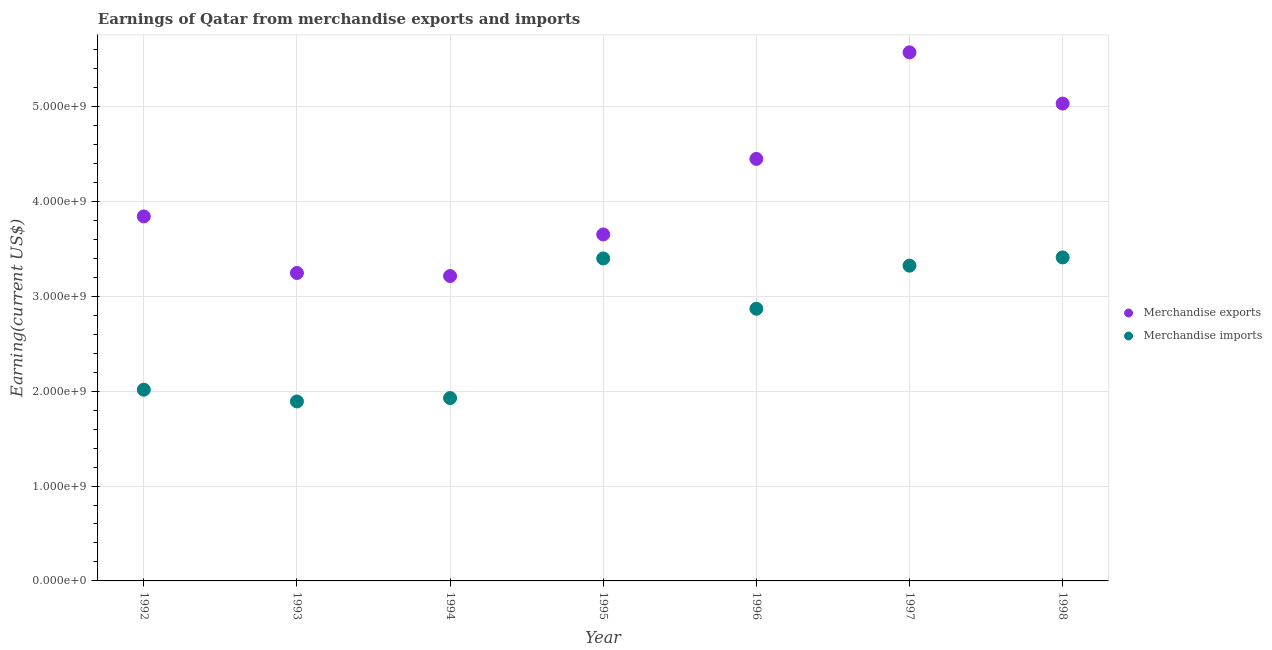How many different coloured dotlines are there?
Provide a short and direct response. 2. Is the number of dotlines equal to the number of legend labels?
Offer a terse response. Yes. What is the earnings from merchandise exports in 1993?
Provide a short and direct response. 3.24e+09. Across all years, what is the maximum earnings from merchandise imports?
Provide a short and direct response. 3.41e+09. Across all years, what is the minimum earnings from merchandise exports?
Provide a succinct answer. 3.21e+09. In which year was the earnings from merchandise exports maximum?
Your response must be concise. 1997. What is the total earnings from merchandise imports in the graph?
Keep it short and to the point. 1.88e+1. What is the difference between the earnings from merchandise exports in 1995 and that in 1997?
Ensure brevity in your answer.  -1.92e+09. What is the difference between the earnings from merchandise exports in 1997 and the earnings from merchandise imports in 1993?
Your response must be concise. 3.68e+09. What is the average earnings from merchandise imports per year?
Keep it short and to the point. 2.69e+09. In the year 1996, what is the difference between the earnings from merchandise exports and earnings from merchandise imports?
Your answer should be compact. 1.58e+09. In how many years, is the earnings from merchandise exports greater than 3400000000 US$?
Offer a terse response. 5. What is the ratio of the earnings from merchandise imports in 1995 to that in 1998?
Provide a short and direct response. 1. What is the difference between the highest and the second highest earnings from merchandise imports?
Offer a very short reply. 1.10e+07. What is the difference between the highest and the lowest earnings from merchandise imports?
Make the answer very short. 1.52e+09. Is the sum of the earnings from merchandise imports in 1994 and 1997 greater than the maximum earnings from merchandise exports across all years?
Ensure brevity in your answer.  No. Is the earnings from merchandise exports strictly greater than the earnings from merchandise imports over the years?
Your answer should be compact. Yes. Is the earnings from merchandise imports strictly less than the earnings from merchandise exports over the years?
Your answer should be very brief. Yes. How many dotlines are there?
Your answer should be compact. 2. How many years are there in the graph?
Your response must be concise. 7. Are the values on the major ticks of Y-axis written in scientific E-notation?
Make the answer very short. Yes. Does the graph contain grids?
Offer a very short reply. Yes. How many legend labels are there?
Your response must be concise. 2. How are the legend labels stacked?
Your response must be concise. Vertical. What is the title of the graph?
Offer a very short reply. Earnings of Qatar from merchandise exports and imports. Does "Total Population" appear as one of the legend labels in the graph?
Make the answer very short. No. What is the label or title of the X-axis?
Provide a short and direct response. Year. What is the label or title of the Y-axis?
Give a very brief answer. Earning(current US$). What is the Earning(current US$) of Merchandise exports in 1992?
Keep it short and to the point. 3.84e+09. What is the Earning(current US$) of Merchandise imports in 1992?
Your answer should be compact. 2.02e+09. What is the Earning(current US$) of Merchandise exports in 1993?
Ensure brevity in your answer.  3.24e+09. What is the Earning(current US$) in Merchandise imports in 1993?
Make the answer very short. 1.89e+09. What is the Earning(current US$) in Merchandise exports in 1994?
Provide a short and direct response. 3.21e+09. What is the Earning(current US$) in Merchandise imports in 1994?
Ensure brevity in your answer.  1.93e+09. What is the Earning(current US$) in Merchandise exports in 1995?
Provide a succinct answer. 3.65e+09. What is the Earning(current US$) of Merchandise imports in 1995?
Your answer should be compact. 3.40e+09. What is the Earning(current US$) of Merchandise exports in 1996?
Provide a short and direct response. 4.45e+09. What is the Earning(current US$) in Merchandise imports in 1996?
Offer a very short reply. 2.87e+09. What is the Earning(current US$) of Merchandise exports in 1997?
Give a very brief answer. 5.57e+09. What is the Earning(current US$) in Merchandise imports in 1997?
Make the answer very short. 3.32e+09. What is the Earning(current US$) of Merchandise exports in 1998?
Ensure brevity in your answer.  5.03e+09. What is the Earning(current US$) in Merchandise imports in 1998?
Ensure brevity in your answer.  3.41e+09. Across all years, what is the maximum Earning(current US$) in Merchandise exports?
Your response must be concise. 5.57e+09. Across all years, what is the maximum Earning(current US$) of Merchandise imports?
Offer a very short reply. 3.41e+09. Across all years, what is the minimum Earning(current US$) in Merchandise exports?
Ensure brevity in your answer.  3.21e+09. Across all years, what is the minimum Earning(current US$) of Merchandise imports?
Ensure brevity in your answer.  1.89e+09. What is the total Earning(current US$) in Merchandise exports in the graph?
Your answer should be very brief. 2.90e+1. What is the total Earning(current US$) in Merchandise imports in the graph?
Make the answer very short. 1.88e+1. What is the difference between the Earning(current US$) of Merchandise exports in 1992 and that in 1993?
Your answer should be compact. 5.96e+08. What is the difference between the Earning(current US$) of Merchandise imports in 1992 and that in 1993?
Keep it short and to the point. 1.24e+08. What is the difference between the Earning(current US$) of Merchandise exports in 1992 and that in 1994?
Your response must be concise. 6.28e+08. What is the difference between the Earning(current US$) in Merchandise imports in 1992 and that in 1994?
Ensure brevity in your answer.  8.80e+07. What is the difference between the Earning(current US$) of Merchandise exports in 1992 and that in 1995?
Provide a short and direct response. 1.90e+08. What is the difference between the Earning(current US$) in Merchandise imports in 1992 and that in 1995?
Keep it short and to the point. -1.38e+09. What is the difference between the Earning(current US$) of Merchandise exports in 1992 and that in 1996?
Offer a very short reply. -6.06e+08. What is the difference between the Earning(current US$) of Merchandise imports in 1992 and that in 1996?
Your response must be concise. -8.53e+08. What is the difference between the Earning(current US$) of Merchandise exports in 1992 and that in 1997?
Ensure brevity in your answer.  -1.73e+09. What is the difference between the Earning(current US$) of Merchandise imports in 1992 and that in 1997?
Your response must be concise. -1.31e+09. What is the difference between the Earning(current US$) in Merchandise exports in 1992 and that in 1998?
Your response must be concise. -1.19e+09. What is the difference between the Earning(current US$) in Merchandise imports in 1992 and that in 1998?
Give a very brief answer. -1.39e+09. What is the difference between the Earning(current US$) in Merchandise exports in 1993 and that in 1994?
Your answer should be very brief. 3.20e+07. What is the difference between the Earning(current US$) in Merchandise imports in 1993 and that in 1994?
Make the answer very short. -3.60e+07. What is the difference between the Earning(current US$) in Merchandise exports in 1993 and that in 1995?
Ensure brevity in your answer.  -4.06e+08. What is the difference between the Earning(current US$) in Merchandise imports in 1993 and that in 1995?
Your answer should be very brief. -1.51e+09. What is the difference between the Earning(current US$) of Merchandise exports in 1993 and that in 1996?
Give a very brief answer. -1.20e+09. What is the difference between the Earning(current US$) in Merchandise imports in 1993 and that in 1996?
Your response must be concise. -9.77e+08. What is the difference between the Earning(current US$) of Merchandise exports in 1993 and that in 1997?
Ensure brevity in your answer.  -2.32e+09. What is the difference between the Earning(current US$) in Merchandise imports in 1993 and that in 1997?
Ensure brevity in your answer.  -1.43e+09. What is the difference between the Earning(current US$) of Merchandise exports in 1993 and that in 1998?
Keep it short and to the point. -1.78e+09. What is the difference between the Earning(current US$) of Merchandise imports in 1993 and that in 1998?
Your response must be concise. -1.52e+09. What is the difference between the Earning(current US$) in Merchandise exports in 1994 and that in 1995?
Make the answer very short. -4.38e+08. What is the difference between the Earning(current US$) of Merchandise imports in 1994 and that in 1995?
Give a very brief answer. -1.47e+09. What is the difference between the Earning(current US$) in Merchandise exports in 1994 and that in 1996?
Your answer should be compact. -1.23e+09. What is the difference between the Earning(current US$) of Merchandise imports in 1994 and that in 1996?
Provide a succinct answer. -9.41e+08. What is the difference between the Earning(current US$) in Merchandise exports in 1994 and that in 1997?
Your response must be concise. -2.36e+09. What is the difference between the Earning(current US$) of Merchandise imports in 1994 and that in 1997?
Your response must be concise. -1.40e+09. What is the difference between the Earning(current US$) of Merchandise exports in 1994 and that in 1998?
Give a very brief answer. -1.82e+09. What is the difference between the Earning(current US$) of Merchandise imports in 1994 and that in 1998?
Offer a terse response. -1.48e+09. What is the difference between the Earning(current US$) in Merchandise exports in 1995 and that in 1996?
Your response must be concise. -7.96e+08. What is the difference between the Earning(current US$) of Merchandise imports in 1995 and that in 1996?
Offer a terse response. 5.30e+08. What is the difference between the Earning(current US$) in Merchandise exports in 1995 and that in 1997?
Ensure brevity in your answer.  -1.92e+09. What is the difference between the Earning(current US$) of Merchandise imports in 1995 and that in 1997?
Your answer should be very brief. 7.60e+07. What is the difference between the Earning(current US$) of Merchandise exports in 1995 and that in 1998?
Offer a terse response. -1.38e+09. What is the difference between the Earning(current US$) in Merchandise imports in 1995 and that in 1998?
Your response must be concise. -1.10e+07. What is the difference between the Earning(current US$) in Merchandise exports in 1996 and that in 1997?
Offer a very short reply. -1.12e+09. What is the difference between the Earning(current US$) of Merchandise imports in 1996 and that in 1997?
Your answer should be compact. -4.54e+08. What is the difference between the Earning(current US$) in Merchandise exports in 1996 and that in 1998?
Provide a short and direct response. -5.83e+08. What is the difference between the Earning(current US$) in Merchandise imports in 1996 and that in 1998?
Offer a very short reply. -5.41e+08. What is the difference between the Earning(current US$) of Merchandise exports in 1997 and that in 1998?
Ensure brevity in your answer.  5.40e+08. What is the difference between the Earning(current US$) in Merchandise imports in 1997 and that in 1998?
Your answer should be compact. -8.70e+07. What is the difference between the Earning(current US$) of Merchandise exports in 1992 and the Earning(current US$) of Merchandise imports in 1993?
Offer a very short reply. 1.95e+09. What is the difference between the Earning(current US$) of Merchandise exports in 1992 and the Earning(current US$) of Merchandise imports in 1994?
Give a very brief answer. 1.91e+09. What is the difference between the Earning(current US$) of Merchandise exports in 1992 and the Earning(current US$) of Merchandise imports in 1995?
Provide a short and direct response. 4.43e+08. What is the difference between the Earning(current US$) in Merchandise exports in 1992 and the Earning(current US$) in Merchandise imports in 1996?
Your answer should be compact. 9.73e+08. What is the difference between the Earning(current US$) of Merchandise exports in 1992 and the Earning(current US$) of Merchandise imports in 1997?
Your answer should be very brief. 5.19e+08. What is the difference between the Earning(current US$) of Merchandise exports in 1992 and the Earning(current US$) of Merchandise imports in 1998?
Ensure brevity in your answer.  4.32e+08. What is the difference between the Earning(current US$) of Merchandise exports in 1993 and the Earning(current US$) of Merchandise imports in 1994?
Make the answer very short. 1.32e+09. What is the difference between the Earning(current US$) in Merchandise exports in 1993 and the Earning(current US$) in Merchandise imports in 1995?
Make the answer very short. -1.53e+08. What is the difference between the Earning(current US$) in Merchandise exports in 1993 and the Earning(current US$) in Merchandise imports in 1996?
Provide a short and direct response. 3.77e+08. What is the difference between the Earning(current US$) of Merchandise exports in 1993 and the Earning(current US$) of Merchandise imports in 1997?
Make the answer very short. -7.70e+07. What is the difference between the Earning(current US$) of Merchandise exports in 1993 and the Earning(current US$) of Merchandise imports in 1998?
Make the answer very short. -1.64e+08. What is the difference between the Earning(current US$) of Merchandise exports in 1994 and the Earning(current US$) of Merchandise imports in 1995?
Ensure brevity in your answer.  -1.85e+08. What is the difference between the Earning(current US$) of Merchandise exports in 1994 and the Earning(current US$) of Merchandise imports in 1996?
Ensure brevity in your answer.  3.45e+08. What is the difference between the Earning(current US$) of Merchandise exports in 1994 and the Earning(current US$) of Merchandise imports in 1997?
Provide a succinct answer. -1.09e+08. What is the difference between the Earning(current US$) in Merchandise exports in 1994 and the Earning(current US$) in Merchandise imports in 1998?
Make the answer very short. -1.96e+08. What is the difference between the Earning(current US$) in Merchandise exports in 1995 and the Earning(current US$) in Merchandise imports in 1996?
Keep it short and to the point. 7.83e+08. What is the difference between the Earning(current US$) of Merchandise exports in 1995 and the Earning(current US$) of Merchandise imports in 1997?
Offer a very short reply. 3.29e+08. What is the difference between the Earning(current US$) in Merchandise exports in 1995 and the Earning(current US$) in Merchandise imports in 1998?
Your answer should be very brief. 2.42e+08. What is the difference between the Earning(current US$) of Merchandise exports in 1996 and the Earning(current US$) of Merchandise imports in 1997?
Provide a succinct answer. 1.12e+09. What is the difference between the Earning(current US$) in Merchandise exports in 1996 and the Earning(current US$) in Merchandise imports in 1998?
Provide a short and direct response. 1.04e+09. What is the difference between the Earning(current US$) in Merchandise exports in 1997 and the Earning(current US$) in Merchandise imports in 1998?
Provide a succinct answer. 2.16e+09. What is the average Earning(current US$) in Merchandise exports per year?
Your response must be concise. 4.14e+09. What is the average Earning(current US$) of Merchandise imports per year?
Your answer should be very brief. 2.69e+09. In the year 1992, what is the difference between the Earning(current US$) of Merchandise exports and Earning(current US$) of Merchandise imports?
Your answer should be compact. 1.83e+09. In the year 1993, what is the difference between the Earning(current US$) in Merchandise exports and Earning(current US$) in Merchandise imports?
Provide a short and direct response. 1.35e+09. In the year 1994, what is the difference between the Earning(current US$) in Merchandise exports and Earning(current US$) in Merchandise imports?
Keep it short and to the point. 1.29e+09. In the year 1995, what is the difference between the Earning(current US$) in Merchandise exports and Earning(current US$) in Merchandise imports?
Your answer should be very brief. 2.53e+08. In the year 1996, what is the difference between the Earning(current US$) in Merchandise exports and Earning(current US$) in Merchandise imports?
Offer a terse response. 1.58e+09. In the year 1997, what is the difference between the Earning(current US$) in Merchandise exports and Earning(current US$) in Merchandise imports?
Your answer should be compact. 2.25e+09. In the year 1998, what is the difference between the Earning(current US$) of Merchandise exports and Earning(current US$) of Merchandise imports?
Offer a very short reply. 1.62e+09. What is the ratio of the Earning(current US$) of Merchandise exports in 1992 to that in 1993?
Your response must be concise. 1.18. What is the ratio of the Earning(current US$) of Merchandise imports in 1992 to that in 1993?
Offer a very short reply. 1.07. What is the ratio of the Earning(current US$) of Merchandise exports in 1992 to that in 1994?
Your response must be concise. 1.2. What is the ratio of the Earning(current US$) in Merchandise imports in 1992 to that in 1994?
Provide a short and direct response. 1.05. What is the ratio of the Earning(current US$) in Merchandise exports in 1992 to that in 1995?
Make the answer very short. 1.05. What is the ratio of the Earning(current US$) of Merchandise imports in 1992 to that in 1995?
Your response must be concise. 0.59. What is the ratio of the Earning(current US$) in Merchandise exports in 1992 to that in 1996?
Make the answer very short. 0.86. What is the ratio of the Earning(current US$) of Merchandise imports in 1992 to that in 1996?
Your answer should be compact. 0.7. What is the ratio of the Earning(current US$) of Merchandise exports in 1992 to that in 1997?
Make the answer very short. 0.69. What is the ratio of the Earning(current US$) in Merchandise imports in 1992 to that in 1997?
Ensure brevity in your answer.  0.61. What is the ratio of the Earning(current US$) in Merchandise exports in 1992 to that in 1998?
Your answer should be very brief. 0.76. What is the ratio of the Earning(current US$) of Merchandise imports in 1992 to that in 1998?
Keep it short and to the point. 0.59. What is the ratio of the Earning(current US$) of Merchandise imports in 1993 to that in 1994?
Make the answer very short. 0.98. What is the ratio of the Earning(current US$) of Merchandise exports in 1993 to that in 1995?
Offer a terse response. 0.89. What is the ratio of the Earning(current US$) of Merchandise imports in 1993 to that in 1995?
Provide a succinct answer. 0.56. What is the ratio of the Earning(current US$) of Merchandise exports in 1993 to that in 1996?
Your answer should be very brief. 0.73. What is the ratio of the Earning(current US$) in Merchandise imports in 1993 to that in 1996?
Your answer should be compact. 0.66. What is the ratio of the Earning(current US$) in Merchandise exports in 1993 to that in 1997?
Your answer should be very brief. 0.58. What is the ratio of the Earning(current US$) of Merchandise imports in 1993 to that in 1997?
Offer a very short reply. 0.57. What is the ratio of the Earning(current US$) in Merchandise exports in 1993 to that in 1998?
Your answer should be compact. 0.65. What is the ratio of the Earning(current US$) of Merchandise imports in 1993 to that in 1998?
Ensure brevity in your answer.  0.55. What is the ratio of the Earning(current US$) of Merchandise exports in 1994 to that in 1995?
Keep it short and to the point. 0.88. What is the ratio of the Earning(current US$) in Merchandise imports in 1994 to that in 1995?
Give a very brief answer. 0.57. What is the ratio of the Earning(current US$) of Merchandise exports in 1994 to that in 1996?
Ensure brevity in your answer.  0.72. What is the ratio of the Earning(current US$) in Merchandise imports in 1994 to that in 1996?
Provide a succinct answer. 0.67. What is the ratio of the Earning(current US$) of Merchandise exports in 1994 to that in 1997?
Provide a short and direct response. 0.58. What is the ratio of the Earning(current US$) in Merchandise imports in 1994 to that in 1997?
Ensure brevity in your answer.  0.58. What is the ratio of the Earning(current US$) in Merchandise exports in 1994 to that in 1998?
Your answer should be very brief. 0.64. What is the ratio of the Earning(current US$) in Merchandise imports in 1994 to that in 1998?
Ensure brevity in your answer.  0.57. What is the ratio of the Earning(current US$) of Merchandise exports in 1995 to that in 1996?
Keep it short and to the point. 0.82. What is the ratio of the Earning(current US$) of Merchandise imports in 1995 to that in 1996?
Offer a very short reply. 1.18. What is the ratio of the Earning(current US$) of Merchandise exports in 1995 to that in 1997?
Ensure brevity in your answer.  0.66. What is the ratio of the Earning(current US$) of Merchandise imports in 1995 to that in 1997?
Offer a terse response. 1.02. What is the ratio of the Earning(current US$) of Merchandise exports in 1995 to that in 1998?
Your answer should be compact. 0.73. What is the ratio of the Earning(current US$) in Merchandise exports in 1996 to that in 1997?
Provide a succinct answer. 0.8. What is the ratio of the Earning(current US$) in Merchandise imports in 1996 to that in 1997?
Ensure brevity in your answer.  0.86. What is the ratio of the Earning(current US$) of Merchandise exports in 1996 to that in 1998?
Your response must be concise. 0.88. What is the ratio of the Earning(current US$) in Merchandise imports in 1996 to that in 1998?
Your answer should be very brief. 0.84. What is the ratio of the Earning(current US$) of Merchandise exports in 1997 to that in 1998?
Provide a short and direct response. 1.11. What is the ratio of the Earning(current US$) of Merchandise imports in 1997 to that in 1998?
Make the answer very short. 0.97. What is the difference between the highest and the second highest Earning(current US$) of Merchandise exports?
Your answer should be compact. 5.40e+08. What is the difference between the highest and the second highest Earning(current US$) of Merchandise imports?
Give a very brief answer. 1.10e+07. What is the difference between the highest and the lowest Earning(current US$) of Merchandise exports?
Provide a succinct answer. 2.36e+09. What is the difference between the highest and the lowest Earning(current US$) of Merchandise imports?
Your response must be concise. 1.52e+09. 